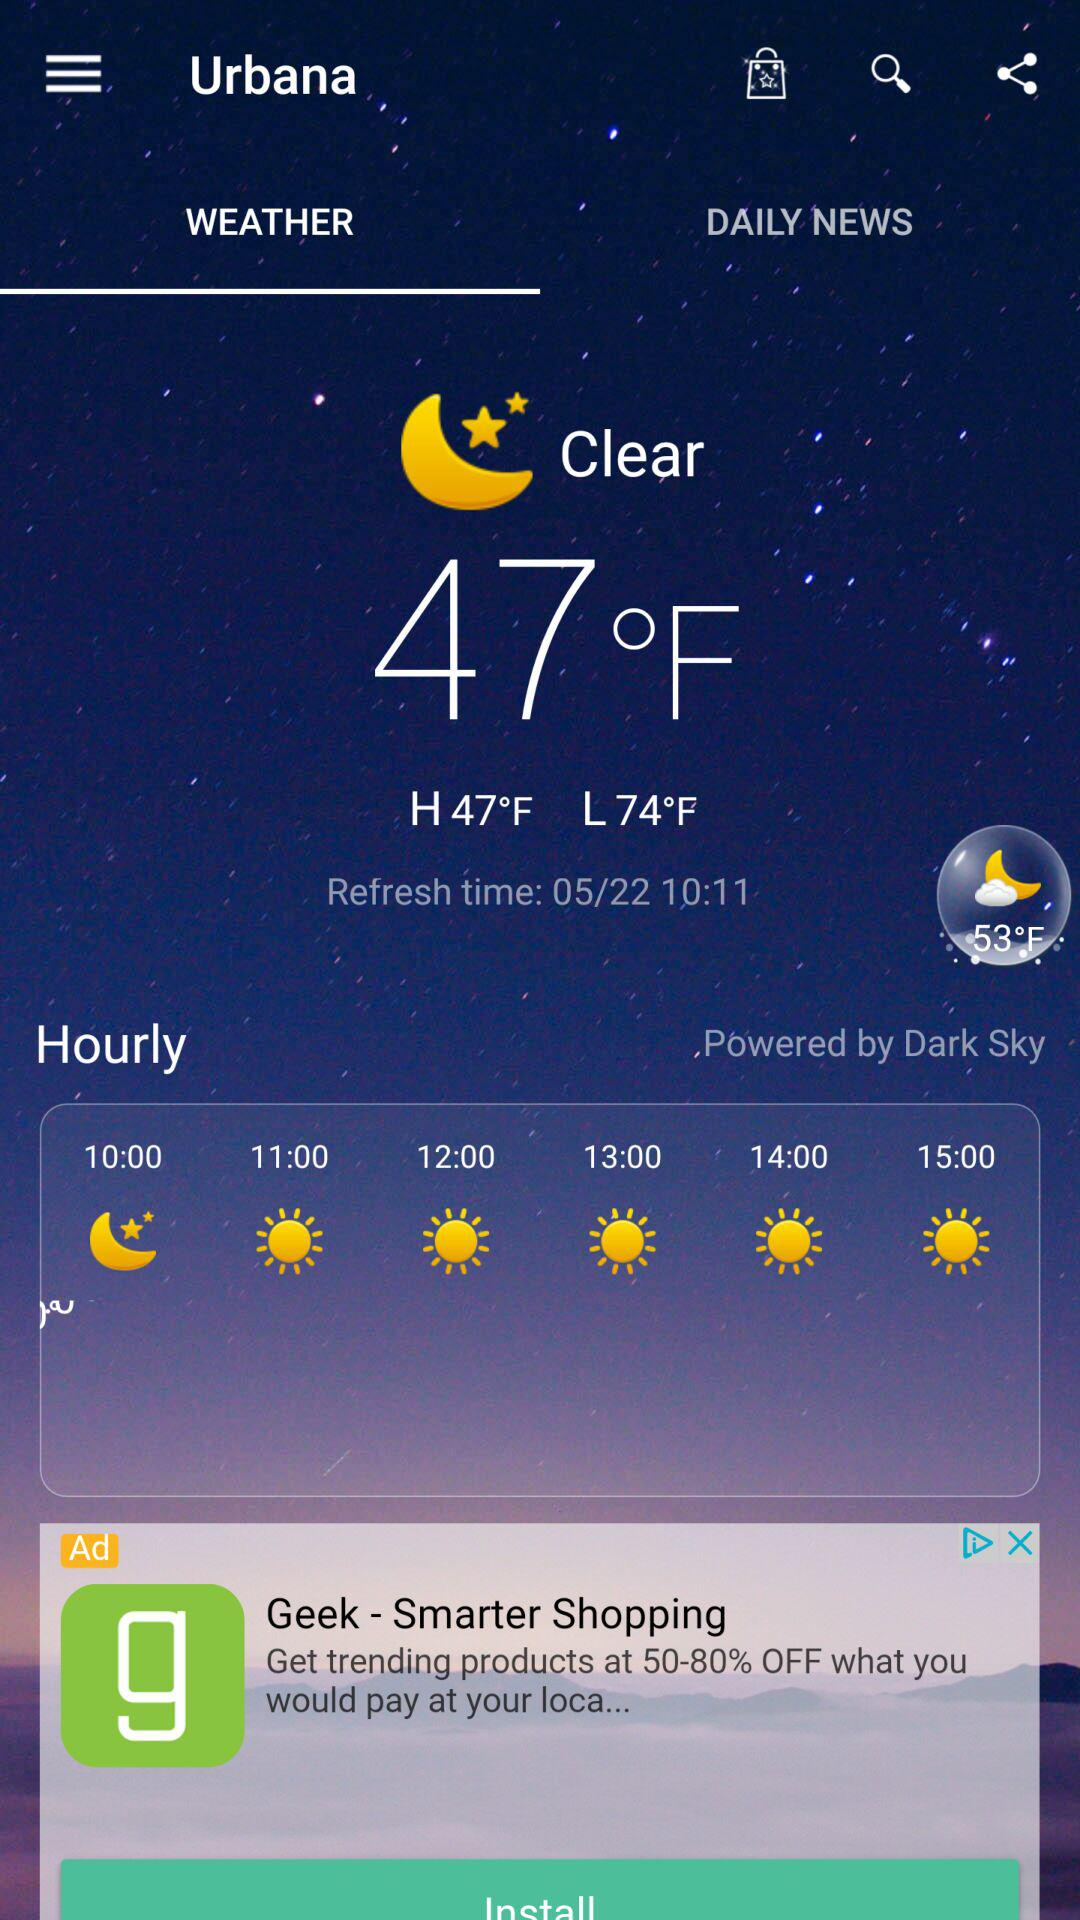How many degrees Fahrenheit is the low temperature?
Answer the question using a single word or phrase. 74°F 